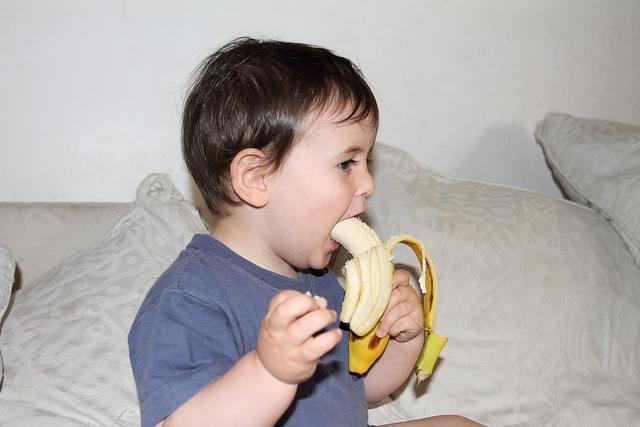What color is the couch?
Answer briefly. Beige. What is the child sitting on?
Keep it brief. Couch. Is this child enjoying his banana?
Be succinct. Yes. 